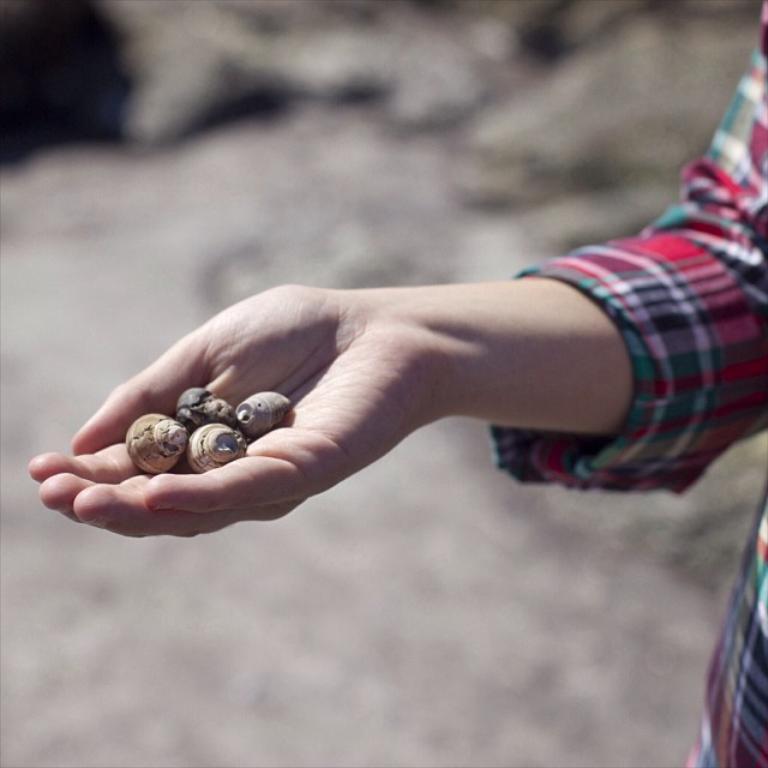How would you summarize this image in a sentence or two? In this image I can see a person hand holding stones. 